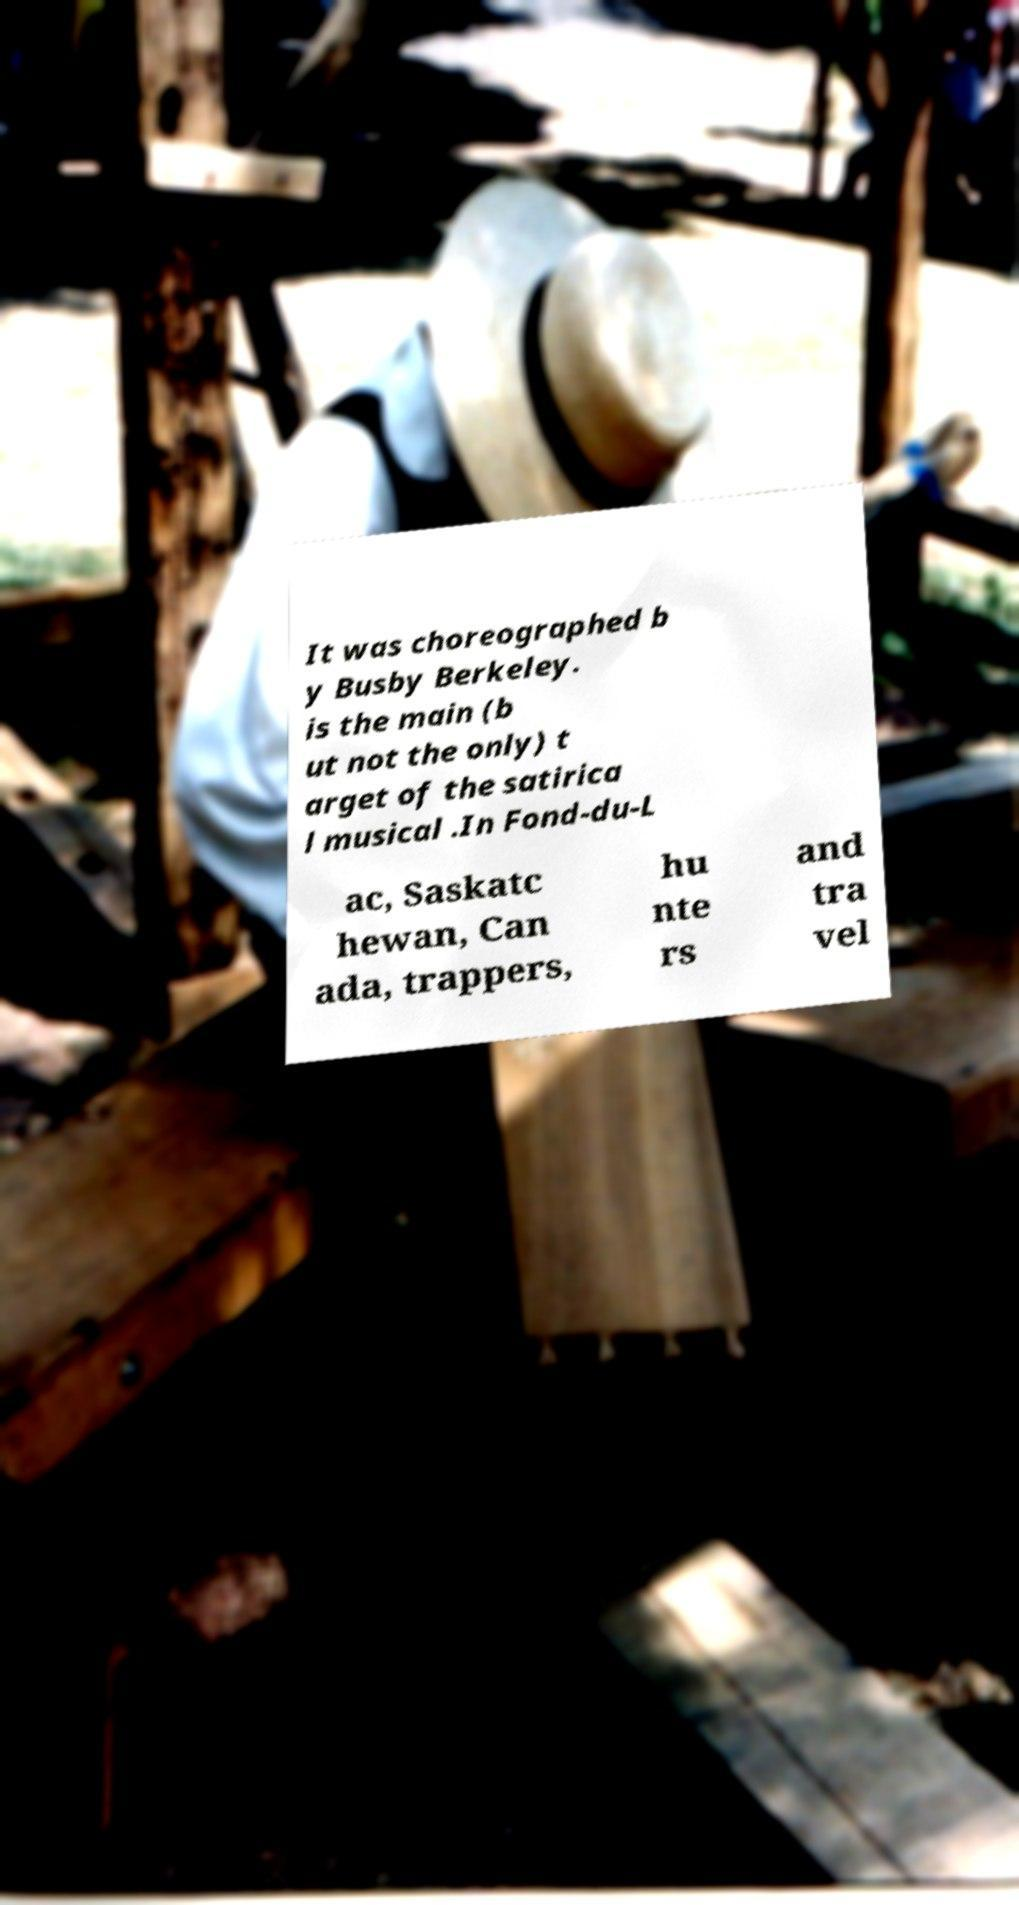What messages or text are displayed in this image? I need them in a readable, typed format. It was choreographed b y Busby Berkeley. is the main (b ut not the only) t arget of the satirica l musical .In Fond-du-L ac, Saskatc hewan, Can ada, trappers, hu nte rs and tra vel 